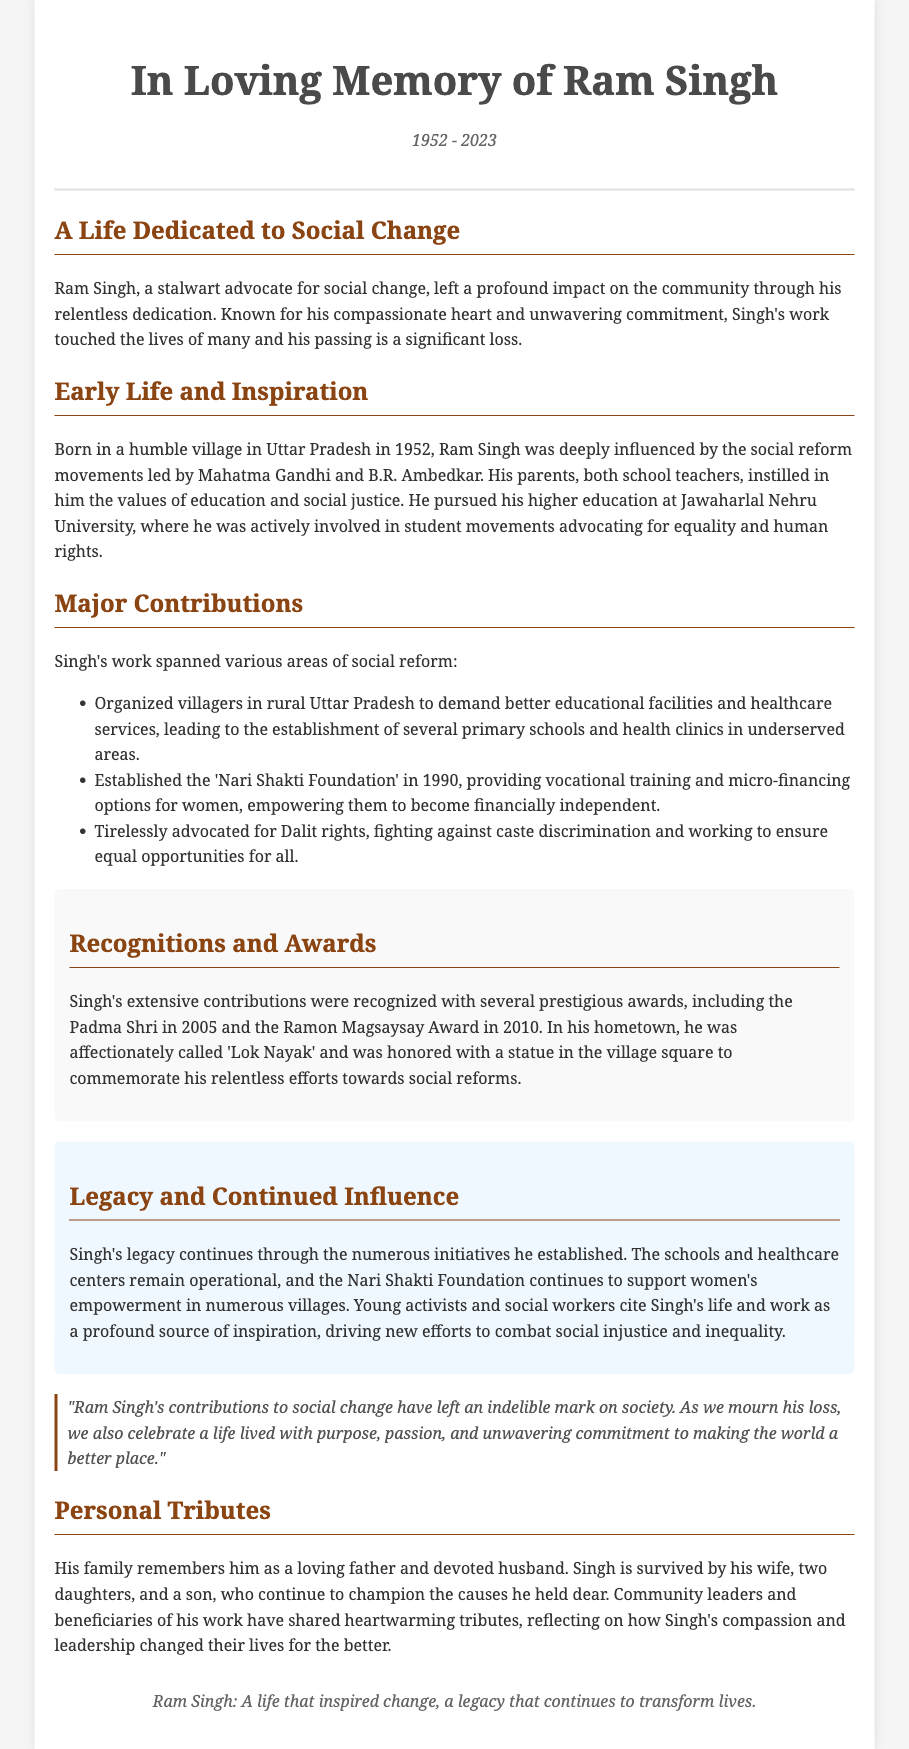What year was Ram Singh born? The document states that Ram Singh was born in 1952.
Answer: 1952 What foundation did Singh establish in 1990? The document mentions that he established the 'Nari Shakti Foundation' in 1990.
Answer: Nari Shakti Foundation Which award did Singh receive in 2005? The document indicates that Singh received the Padma Shri in 2005.
Answer: Padma Shri How many children did Ram Singh have? The document states that he is survived by two daughters and a son, which totals three children.
Answer: three What influenced Ram Singh's dedication to social justice? The document notes he was deeply influenced by the social reform movements led by Mahatma Gandhi and B.R. Ambedkar.
Answer: Mahatma Gandhi and B.R. Ambedkar What is Ram Singh affectionately called in his hometown? The document refers to Singh as 'Lok Nayak' in his hometown.
Answer: Lok Nayak What type of activism did Singh focus on regarding women? The document describes Singh's activism towards providing vocational training and micro-financing options for women.
Answer: women's empowerment What is the overarching theme of Ram Singh's legacy? The document indicates that his legacy continues to inspire new efforts to combat social injustice and inequality.
Answer: social injustice and inequality 